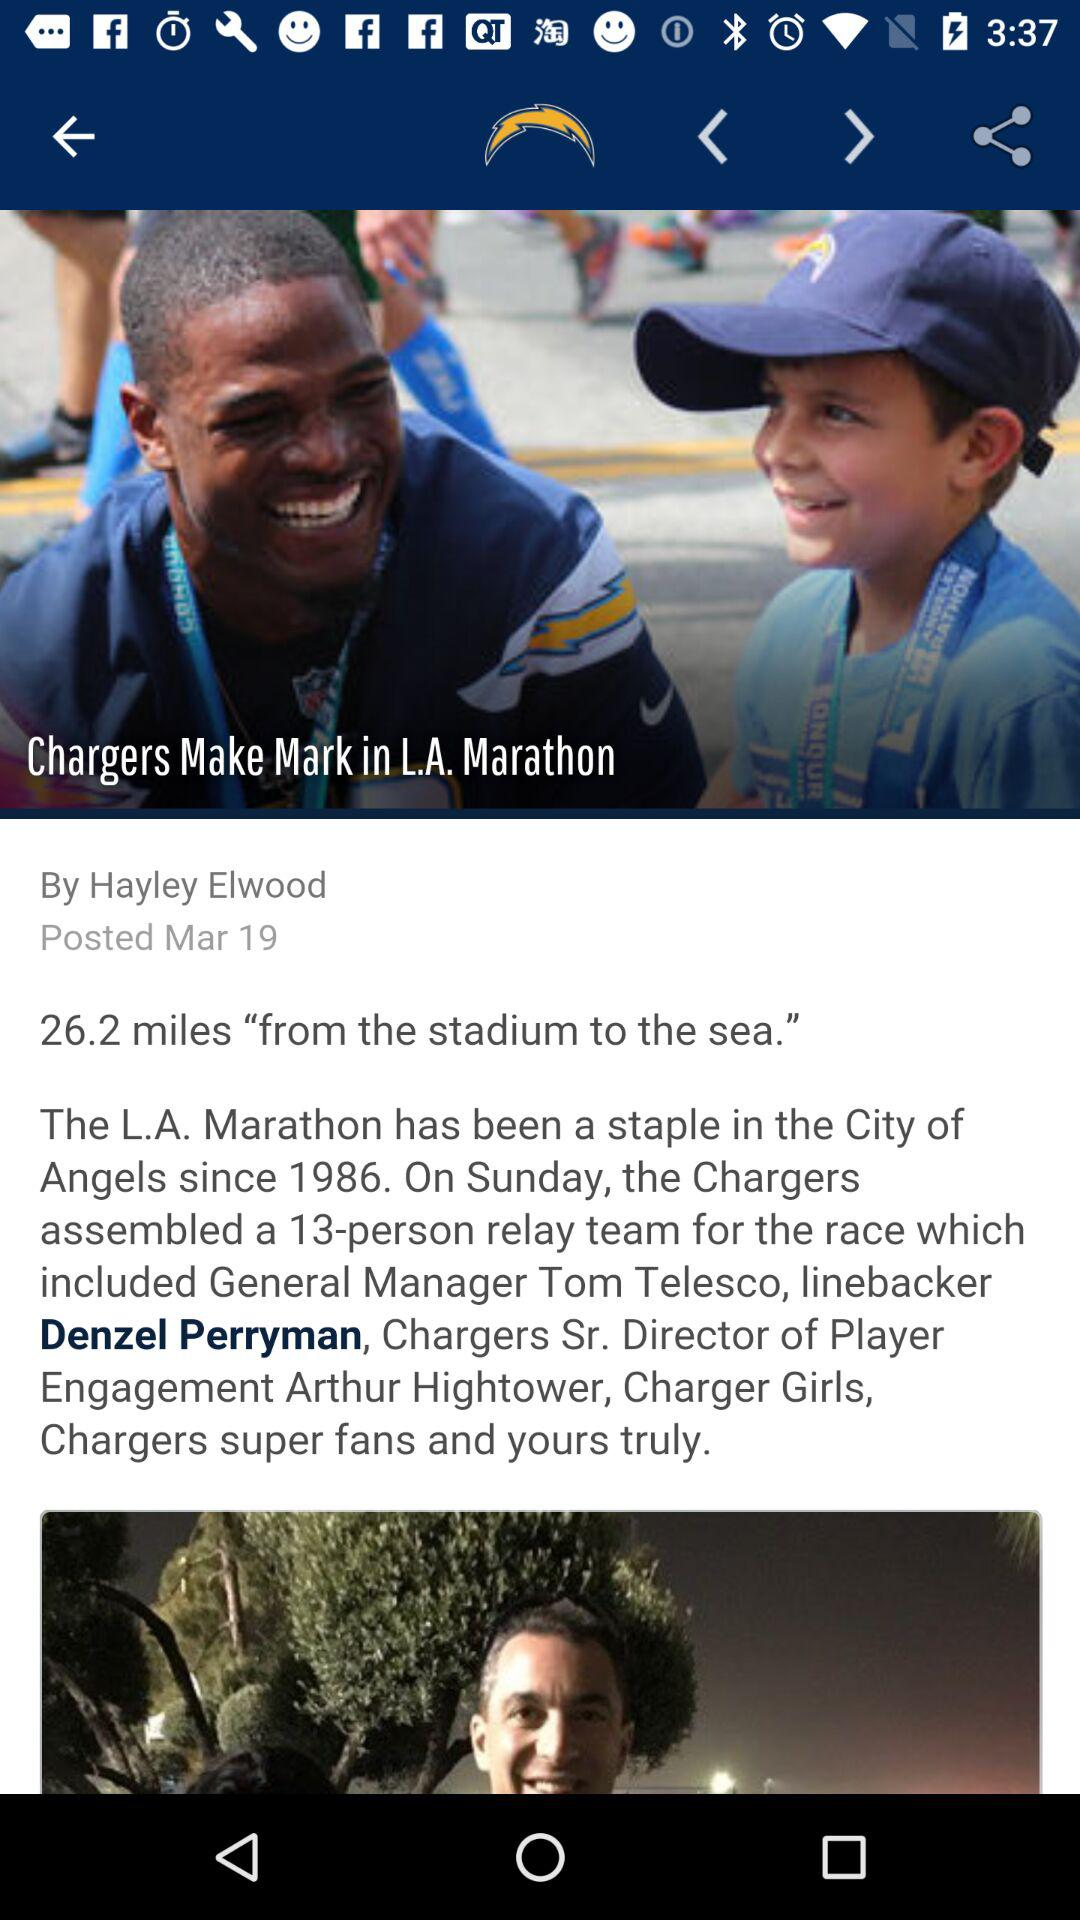What is the author name? The author name is Hayley Elwood. 